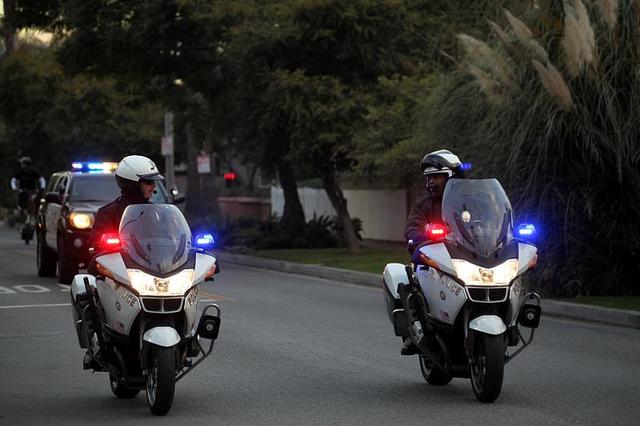What are the cops riding?
Be succinct. Motorcycles. Is it windy?
Answer briefly. Yes. What color are the lights?
Write a very short answer. Red and blue. 